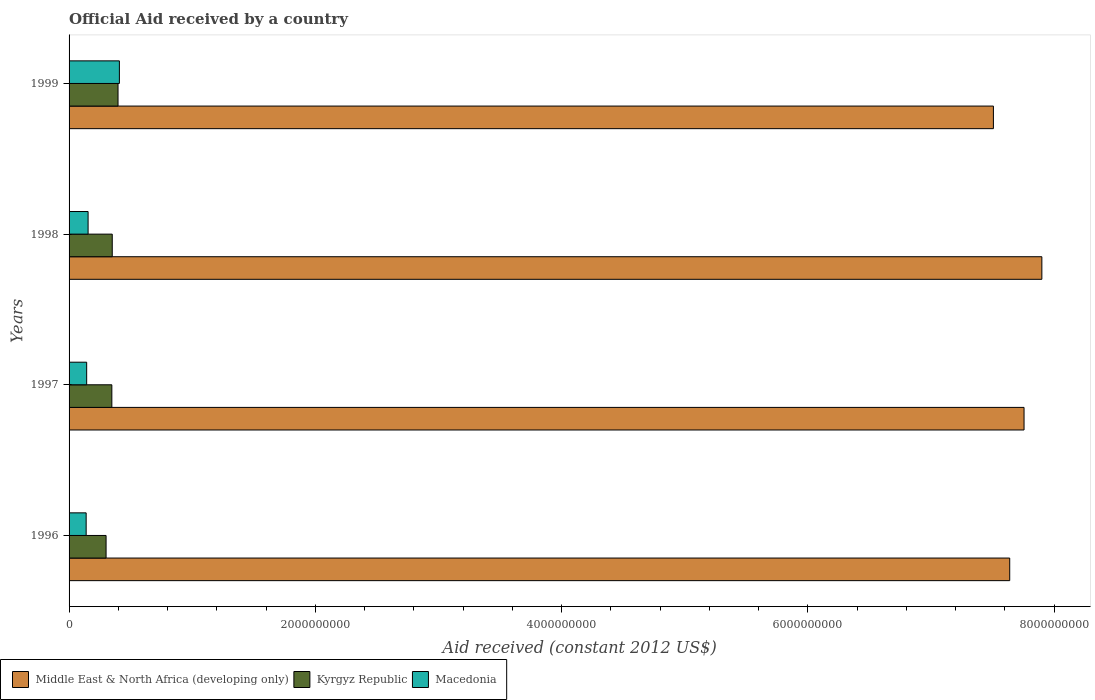How many different coloured bars are there?
Your answer should be compact. 3. In how many cases, is the number of bars for a given year not equal to the number of legend labels?
Make the answer very short. 0. What is the net official aid received in Macedonia in 1998?
Your answer should be very brief. 1.54e+08. Across all years, what is the maximum net official aid received in Kyrgyz Republic?
Give a very brief answer. 3.98e+08. Across all years, what is the minimum net official aid received in Middle East & North Africa (developing only)?
Offer a very short reply. 7.51e+09. In which year was the net official aid received in Macedonia maximum?
Your answer should be very brief. 1999. In which year was the net official aid received in Middle East & North Africa (developing only) minimum?
Offer a terse response. 1999. What is the total net official aid received in Macedonia in the graph?
Ensure brevity in your answer.  8.45e+08. What is the difference between the net official aid received in Macedonia in 1998 and that in 1999?
Offer a very short reply. -2.54e+08. What is the difference between the net official aid received in Kyrgyz Republic in 1997 and the net official aid received in Middle East & North Africa (developing only) in 1999?
Your answer should be very brief. -7.16e+09. What is the average net official aid received in Kyrgyz Republic per year?
Provide a short and direct response. 3.49e+08. In the year 1998, what is the difference between the net official aid received in Middle East & North Africa (developing only) and net official aid received in Macedonia?
Your answer should be compact. 7.75e+09. In how many years, is the net official aid received in Macedonia greater than 2400000000 US$?
Make the answer very short. 0. What is the ratio of the net official aid received in Middle East & North Africa (developing only) in 1997 to that in 1998?
Give a very brief answer. 0.98. Is the net official aid received in Kyrgyz Republic in 1997 less than that in 1999?
Offer a terse response. Yes. Is the difference between the net official aid received in Middle East & North Africa (developing only) in 1996 and 1999 greater than the difference between the net official aid received in Macedonia in 1996 and 1999?
Ensure brevity in your answer.  Yes. What is the difference between the highest and the second highest net official aid received in Kyrgyz Republic?
Your answer should be compact. 4.70e+07. What is the difference between the highest and the lowest net official aid received in Kyrgyz Republic?
Make the answer very short. 9.71e+07. Is the sum of the net official aid received in Middle East & North Africa (developing only) in 1997 and 1998 greater than the maximum net official aid received in Macedonia across all years?
Offer a terse response. Yes. What does the 1st bar from the top in 1998 represents?
Provide a short and direct response. Macedonia. What does the 3rd bar from the bottom in 1999 represents?
Give a very brief answer. Macedonia. How many years are there in the graph?
Offer a very short reply. 4. What is the difference between two consecutive major ticks on the X-axis?
Offer a very short reply. 2.00e+09. Are the values on the major ticks of X-axis written in scientific E-notation?
Give a very brief answer. No. Does the graph contain any zero values?
Offer a very short reply. No. Does the graph contain grids?
Ensure brevity in your answer.  No. How are the legend labels stacked?
Ensure brevity in your answer.  Horizontal. What is the title of the graph?
Your answer should be compact. Official Aid received by a country. Does "United States" appear as one of the legend labels in the graph?
Give a very brief answer. No. What is the label or title of the X-axis?
Your answer should be compact. Aid received (constant 2012 US$). What is the Aid received (constant 2012 US$) in Middle East & North Africa (developing only) in 1996?
Offer a very short reply. 7.64e+09. What is the Aid received (constant 2012 US$) of Kyrgyz Republic in 1996?
Provide a succinct answer. 3.01e+08. What is the Aid received (constant 2012 US$) of Macedonia in 1996?
Make the answer very short. 1.39e+08. What is the Aid received (constant 2012 US$) of Middle East & North Africa (developing only) in 1997?
Your response must be concise. 7.76e+09. What is the Aid received (constant 2012 US$) in Kyrgyz Republic in 1997?
Provide a short and direct response. 3.47e+08. What is the Aid received (constant 2012 US$) in Macedonia in 1997?
Your answer should be very brief. 1.43e+08. What is the Aid received (constant 2012 US$) of Middle East & North Africa (developing only) in 1998?
Give a very brief answer. 7.90e+09. What is the Aid received (constant 2012 US$) in Kyrgyz Republic in 1998?
Make the answer very short. 3.51e+08. What is the Aid received (constant 2012 US$) in Macedonia in 1998?
Give a very brief answer. 1.54e+08. What is the Aid received (constant 2012 US$) in Middle East & North Africa (developing only) in 1999?
Your answer should be very brief. 7.51e+09. What is the Aid received (constant 2012 US$) of Kyrgyz Republic in 1999?
Offer a terse response. 3.98e+08. What is the Aid received (constant 2012 US$) in Macedonia in 1999?
Your answer should be compact. 4.09e+08. Across all years, what is the maximum Aid received (constant 2012 US$) of Middle East & North Africa (developing only)?
Your answer should be very brief. 7.90e+09. Across all years, what is the maximum Aid received (constant 2012 US$) of Kyrgyz Republic?
Provide a succinct answer. 3.98e+08. Across all years, what is the maximum Aid received (constant 2012 US$) of Macedonia?
Ensure brevity in your answer.  4.09e+08. Across all years, what is the minimum Aid received (constant 2012 US$) of Middle East & North Africa (developing only)?
Ensure brevity in your answer.  7.51e+09. Across all years, what is the minimum Aid received (constant 2012 US$) in Kyrgyz Republic?
Offer a terse response. 3.01e+08. Across all years, what is the minimum Aid received (constant 2012 US$) of Macedonia?
Ensure brevity in your answer.  1.39e+08. What is the total Aid received (constant 2012 US$) in Middle East & North Africa (developing only) in the graph?
Ensure brevity in your answer.  3.08e+1. What is the total Aid received (constant 2012 US$) in Kyrgyz Republic in the graph?
Offer a very short reply. 1.40e+09. What is the total Aid received (constant 2012 US$) of Macedonia in the graph?
Offer a terse response. 8.45e+08. What is the difference between the Aid received (constant 2012 US$) in Middle East & North Africa (developing only) in 1996 and that in 1997?
Provide a succinct answer. -1.16e+08. What is the difference between the Aid received (constant 2012 US$) of Kyrgyz Republic in 1996 and that in 1997?
Make the answer very short. -4.69e+07. What is the difference between the Aid received (constant 2012 US$) of Macedonia in 1996 and that in 1997?
Ensure brevity in your answer.  -4.11e+06. What is the difference between the Aid received (constant 2012 US$) in Middle East & North Africa (developing only) in 1996 and that in 1998?
Your response must be concise. -2.61e+08. What is the difference between the Aid received (constant 2012 US$) of Kyrgyz Republic in 1996 and that in 1998?
Keep it short and to the point. -5.01e+07. What is the difference between the Aid received (constant 2012 US$) of Macedonia in 1996 and that in 1998?
Offer a terse response. -1.57e+07. What is the difference between the Aid received (constant 2012 US$) in Middle East & North Africa (developing only) in 1996 and that in 1999?
Provide a succinct answer. 1.32e+08. What is the difference between the Aid received (constant 2012 US$) in Kyrgyz Republic in 1996 and that in 1999?
Offer a very short reply. -9.71e+07. What is the difference between the Aid received (constant 2012 US$) of Macedonia in 1996 and that in 1999?
Keep it short and to the point. -2.70e+08. What is the difference between the Aid received (constant 2012 US$) in Middle East & North Africa (developing only) in 1997 and that in 1998?
Your response must be concise. -1.45e+08. What is the difference between the Aid received (constant 2012 US$) in Kyrgyz Republic in 1997 and that in 1998?
Give a very brief answer. -3.21e+06. What is the difference between the Aid received (constant 2012 US$) of Macedonia in 1997 and that in 1998?
Keep it short and to the point. -1.16e+07. What is the difference between the Aid received (constant 2012 US$) of Middle East & North Africa (developing only) in 1997 and that in 1999?
Offer a terse response. 2.49e+08. What is the difference between the Aid received (constant 2012 US$) of Kyrgyz Republic in 1997 and that in 1999?
Offer a very short reply. -5.02e+07. What is the difference between the Aid received (constant 2012 US$) in Macedonia in 1997 and that in 1999?
Keep it short and to the point. -2.66e+08. What is the difference between the Aid received (constant 2012 US$) of Middle East & North Africa (developing only) in 1998 and that in 1999?
Ensure brevity in your answer.  3.93e+08. What is the difference between the Aid received (constant 2012 US$) in Kyrgyz Republic in 1998 and that in 1999?
Make the answer very short. -4.70e+07. What is the difference between the Aid received (constant 2012 US$) in Macedonia in 1998 and that in 1999?
Provide a succinct answer. -2.54e+08. What is the difference between the Aid received (constant 2012 US$) of Middle East & North Africa (developing only) in 1996 and the Aid received (constant 2012 US$) of Kyrgyz Republic in 1997?
Ensure brevity in your answer.  7.29e+09. What is the difference between the Aid received (constant 2012 US$) of Middle East & North Africa (developing only) in 1996 and the Aid received (constant 2012 US$) of Macedonia in 1997?
Make the answer very short. 7.50e+09. What is the difference between the Aid received (constant 2012 US$) of Kyrgyz Republic in 1996 and the Aid received (constant 2012 US$) of Macedonia in 1997?
Provide a succinct answer. 1.58e+08. What is the difference between the Aid received (constant 2012 US$) in Middle East & North Africa (developing only) in 1996 and the Aid received (constant 2012 US$) in Kyrgyz Republic in 1998?
Make the answer very short. 7.29e+09. What is the difference between the Aid received (constant 2012 US$) of Middle East & North Africa (developing only) in 1996 and the Aid received (constant 2012 US$) of Macedonia in 1998?
Provide a succinct answer. 7.49e+09. What is the difference between the Aid received (constant 2012 US$) in Kyrgyz Republic in 1996 and the Aid received (constant 2012 US$) in Macedonia in 1998?
Ensure brevity in your answer.  1.46e+08. What is the difference between the Aid received (constant 2012 US$) of Middle East & North Africa (developing only) in 1996 and the Aid received (constant 2012 US$) of Kyrgyz Republic in 1999?
Ensure brevity in your answer.  7.24e+09. What is the difference between the Aid received (constant 2012 US$) in Middle East & North Africa (developing only) in 1996 and the Aid received (constant 2012 US$) in Macedonia in 1999?
Your response must be concise. 7.23e+09. What is the difference between the Aid received (constant 2012 US$) of Kyrgyz Republic in 1996 and the Aid received (constant 2012 US$) of Macedonia in 1999?
Make the answer very short. -1.08e+08. What is the difference between the Aid received (constant 2012 US$) in Middle East & North Africa (developing only) in 1997 and the Aid received (constant 2012 US$) in Kyrgyz Republic in 1998?
Provide a short and direct response. 7.41e+09. What is the difference between the Aid received (constant 2012 US$) of Middle East & North Africa (developing only) in 1997 and the Aid received (constant 2012 US$) of Macedonia in 1998?
Your answer should be very brief. 7.60e+09. What is the difference between the Aid received (constant 2012 US$) in Kyrgyz Republic in 1997 and the Aid received (constant 2012 US$) in Macedonia in 1998?
Make the answer very short. 1.93e+08. What is the difference between the Aid received (constant 2012 US$) in Middle East & North Africa (developing only) in 1997 and the Aid received (constant 2012 US$) in Kyrgyz Republic in 1999?
Your answer should be very brief. 7.36e+09. What is the difference between the Aid received (constant 2012 US$) of Middle East & North Africa (developing only) in 1997 and the Aid received (constant 2012 US$) of Macedonia in 1999?
Your answer should be compact. 7.35e+09. What is the difference between the Aid received (constant 2012 US$) of Kyrgyz Republic in 1997 and the Aid received (constant 2012 US$) of Macedonia in 1999?
Make the answer very short. -6.12e+07. What is the difference between the Aid received (constant 2012 US$) of Middle East & North Africa (developing only) in 1998 and the Aid received (constant 2012 US$) of Kyrgyz Republic in 1999?
Offer a very short reply. 7.50e+09. What is the difference between the Aid received (constant 2012 US$) of Middle East & North Africa (developing only) in 1998 and the Aid received (constant 2012 US$) of Macedonia in 1999?
Your answer should be compact. 7.49e+09. What is the difference between the Aid received (constant 2012 US$) in Kyrgyz Republic in 1998 and the Aid received (constant 2012 US$) in Macedonia in 1999?
Your response must be concise. -5.80e+07. What is the average Aid received (constant 2012 US$) of Middle East & North Africa (developing only) per year?
Keep it short and to the point. 7.70e+09. What is the average Aid received (constant 2012 US$) of Kyrgyz Republic per year?
Offer a terse response. 3.49e+08. What is the average Aid received (constant 2012 US$) in Macedonia per year?
Offer a very short reply. 2.11e+08. In the year 1996, what is the difference between the Aid received (constant 2012 US$) of Middle East & North Africa (developing only) and Aid received (constant 2012 US$) of Kyrgyz Republic?
Your response must be concise. 7.34e+09. In the year 1996, what is the difference between the Aid received (constant 2012 US$) in Middle East & North Africa (developing only) and Aid received (constant 2012 US$) in Macedonia?
Provide a succinct answer. 7.50e+09. In the year 1996, what is the difference between the Aid received (constant 2012 US$) of Kyrgyz Republic and Aid received (constant 2012 US$) of Macedonia?
Ensure brevity in your answer.  1.62e+08. In the year 1997, what is the difference between the Aid received (constant 2012 US$) of Middle East & North Africa (developing only) and Aid received (constant 2012 US$) of Kyrgyz Republic?
Provide a short and direct response. 7.41e+09. In the year 1997, what is the difference between the Aid received (constant 2012 US$) in Middle East & North Africa (developing only) and Aid received (constant 2012 US$) in Macedonia?
Ensure brevity in your answer.  7.61e+09. In the year 1997, what is the difference between the Aid received (constant 2012 US$) of Kyrgyz Republic and Aid received (constant 2012 US$) of Macedonia?
Provide a succinct answer. 2.05e+08. In the year 1998, what is the difference between the Aid received (constant 2012 US$) in Middle East & North Africa (developing only) and Aid received (constant 2012 US$) in Kyrgyz Republic?
Your answer should be compact. 7.55e+09. In the year 1998, what is the difference between the Aid received (constant 2012 US$) in Middle East & North Africa (developing only) and Aid received (constant 2012 US$) in Macedonia?
Your answer should be compact. 7.75e+09. In the year 1998, what is the difference between the Aid received (constant 2012 US$) in Kyrgyz Republic and Aid received (constant 2012 US$) in Macedonia?
Make the answer very short. 1.96e+08. In the year 1999, what is the difference between the Aid received (constant 2012 US$) in Middle East & North Africa (developing only) and Aid received (constant 2012 US$) in Kyrgyz Republic?
Give a very brief answer. 7.11e+09. In the year 1999, what is the difference between the Aid received (constant 2012 US$) of Middle East & North Africa (developing only) and Aid received (constant 2012 US$) of Macedonia?
Your answer should be compact. 7.10e+09. In the year 1999, what is the difference between the Aid received (constant 2012 US$) in Kyrgyz Republic and Aid received (constant 2012 US$) in Macedonia?
Keep it short and to the point. -1.11e+07. What is the ratio of the Aid received (constant 2012 US$) of Kyrgyz Republic in 1996 to that in 1997?
Offer a very short reply. 0.86. What is the ratio of the Aid received (constant 2012 US$) of Macedonia in 1996 to that in 1997?
Offer a terse response. 0.97. What is the ratio of the Aid received (constant 2012 US$) in Middle East & North Africa (developing only) in 1996 to that in 1998?
Offer a very short reply. 0.97. What is the ratio of the Aid received (constant 2012 US$) in Macedonia in 1996 to that in 1998?
Your answer should be compact. 0.9. What is the ratio of the Aid received (constant 2012 US$) in Middle East & North Africa (developing only) in 1996 to that in 1999?
Make the answer very short. 1.02. What is the ratio of the Aid received (constant 2012 US$) of Kyrgyz Republic in 1996 to that in 1999?
Ensure brevity in your answer.  0.76. What is the ratio of the Aid received (constant 2012 US$) of Macedonia in 1996 to that in 1999?
Your response must be concise. 0.34. What is the ratio of the Aid received (constant 2012 US$) of Middle East & North Africa (developing only) in 1997 to that in 1998?
Ensure brevity in your answer.  0.98. What is the ratio of the Aid received (constant 2012 US$) of Kyrgyz Republic in 1997 to that in 1998?
Your answer should be very brief. 0.99. What is the ratio of the Aid received (constant 2012 US$) in Macedonia in 1997 to that in 1998?
Make the answer very short. 0.93. What is the ratio of the Aid received (constant 2012 US$) of Middle East & North Africa (developing only) in 1997 to that in 1999?
Your response must be concise. 1.03. What is the ratio of the Aid received (constant 2012 US$) in Kyrgyz Republic in 1997 to that in 1999?
Your answer should be very brief. 0.87. What is the ratio of the Aid received (constant 2012 US$) in Macedonia in 1997 to that in 1999?
Your answer should be compact. 0.35. What is the ratio of the Aid received (constant 2012 US$) in Middle East & North Africa (developing only) in 1998 to that in 1999?
Your response must be concise. 1.05. What is the ratio of the Aid received (constant 2012 US$) of Kyrgyz Republic in 1998 to that in 1999?
Offer a terse response. 0.88. What is the ratio of the Aid received (constant 2012 US$) in Macedonia in 1998 to that in 1999?
Your answer should be compact. 0.38. What is the difference between the highest and the second highest Aid received (constant 2012 US$) of Middle East & North Africa (developing only)?
Ensure brevity in your answer.  1.45e+08. What is the difference between the highest and the second highest Aid received (constant 2012 US$) in Kyrgyz Republic?
Offer a very short reply. 4.70e+07. What is the difference between the highest and the second highest Aid received (constant 2012 US$) of Macedonia?
Provide a short and direct response. 2.54e+08. What is the difference between the highest and the lowest Aid received (constant 2012 US$) in Middle East & North Africa (developing only)?
Give a very brief answer. 3.93e+08. What is the difference between the highest and the lowest Aid received (constant 2012 US$) in Kyrgyz Republic?
Offer a terse response. 9.71e+07. What is the difference between the highest and the lowest Aid received (constant 2012 US$) in Macedonia?
Provide a succinct answer. 2.70e+08. 